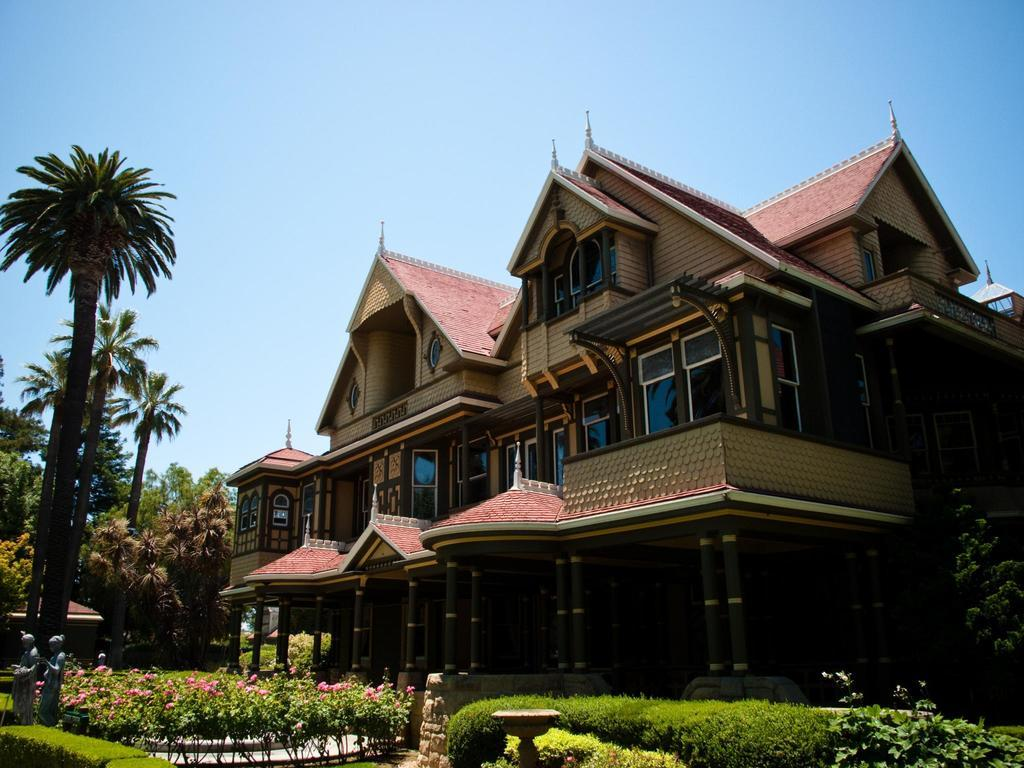What type of structures can be seen in the image? There are buildings in the image. What architectural features can be observed on the buildings? There are windows visible on the buildings. What type of vegetation is present in the image? There are plants, flowers, and trees in the image. What part of the natural environment is visible in the image? The sky is visible in the image. What type of weather can be seen attacking the buildings in the image? There is no weather or attack present in the image; the buildings and vegetation are stationary. Can you tell me how many stars are visible in the image? There are no stars visible in the image, as it primarily features buildings, vegetation, and the sky. 